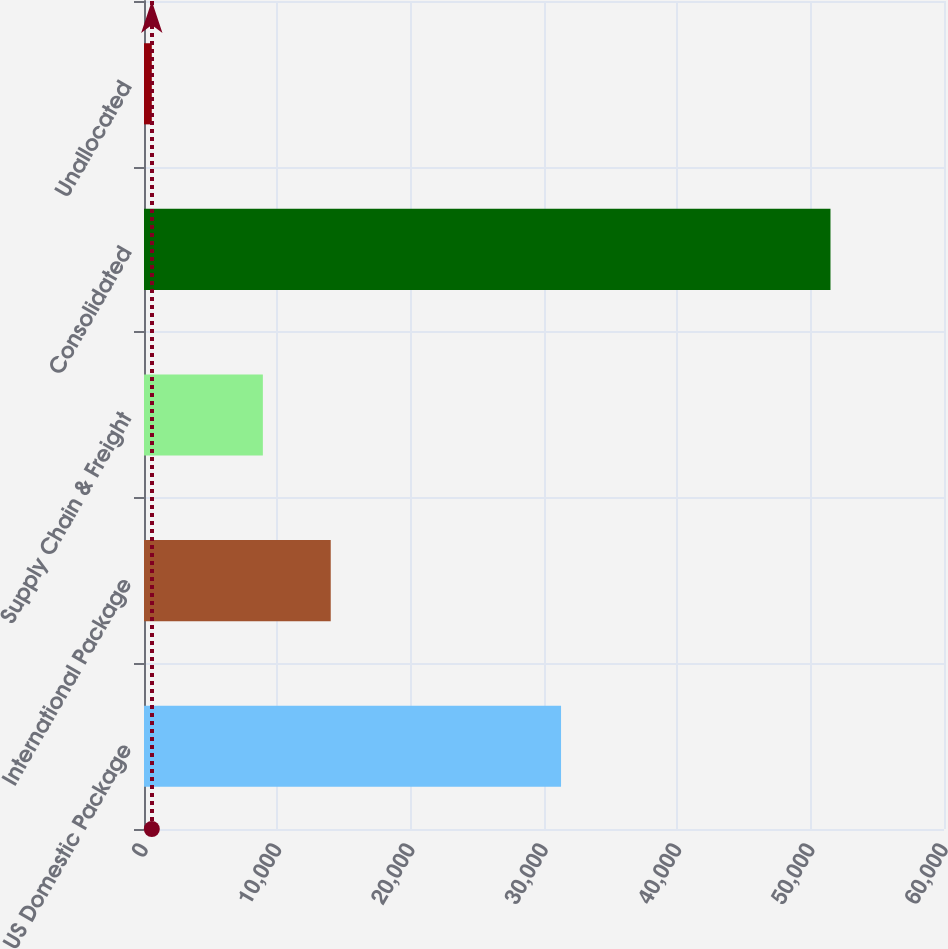Convert chart. <chart><loc_0><loc_0><loc_500><loc_500><bar_chart><fcel>US Domestic Package<fcel>International Package<fcel>Supply Chain & Freight<fcel>Consolidated<fcel>Unallocated<nl><fcel>31278<fcel>14005.1<fcel>8915<fcel>51486<fcel>585<nl></chart> 